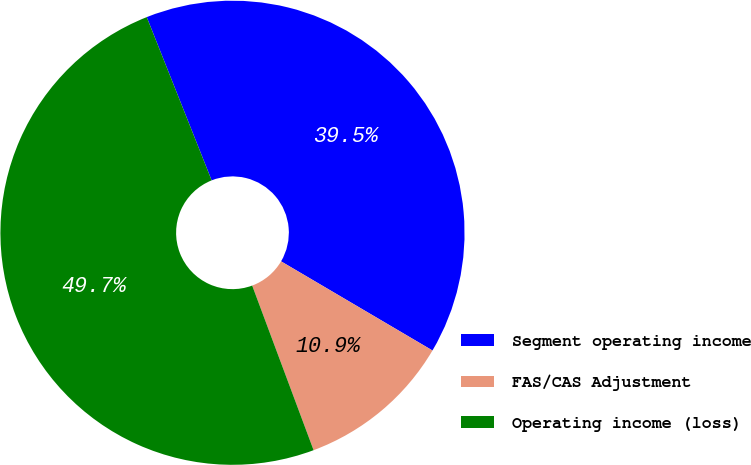Convert chart to OTSL. <chart><loc_0><loc_0><loc_500><loc_500><pie_chart><fcel>Segment operating income<fcel>FAS/CAS Adjustment<fcel>Operating income (loss)<nl><fcel>39.49%<fcel>10.85%<fcel>49.66%<nl></chart> 